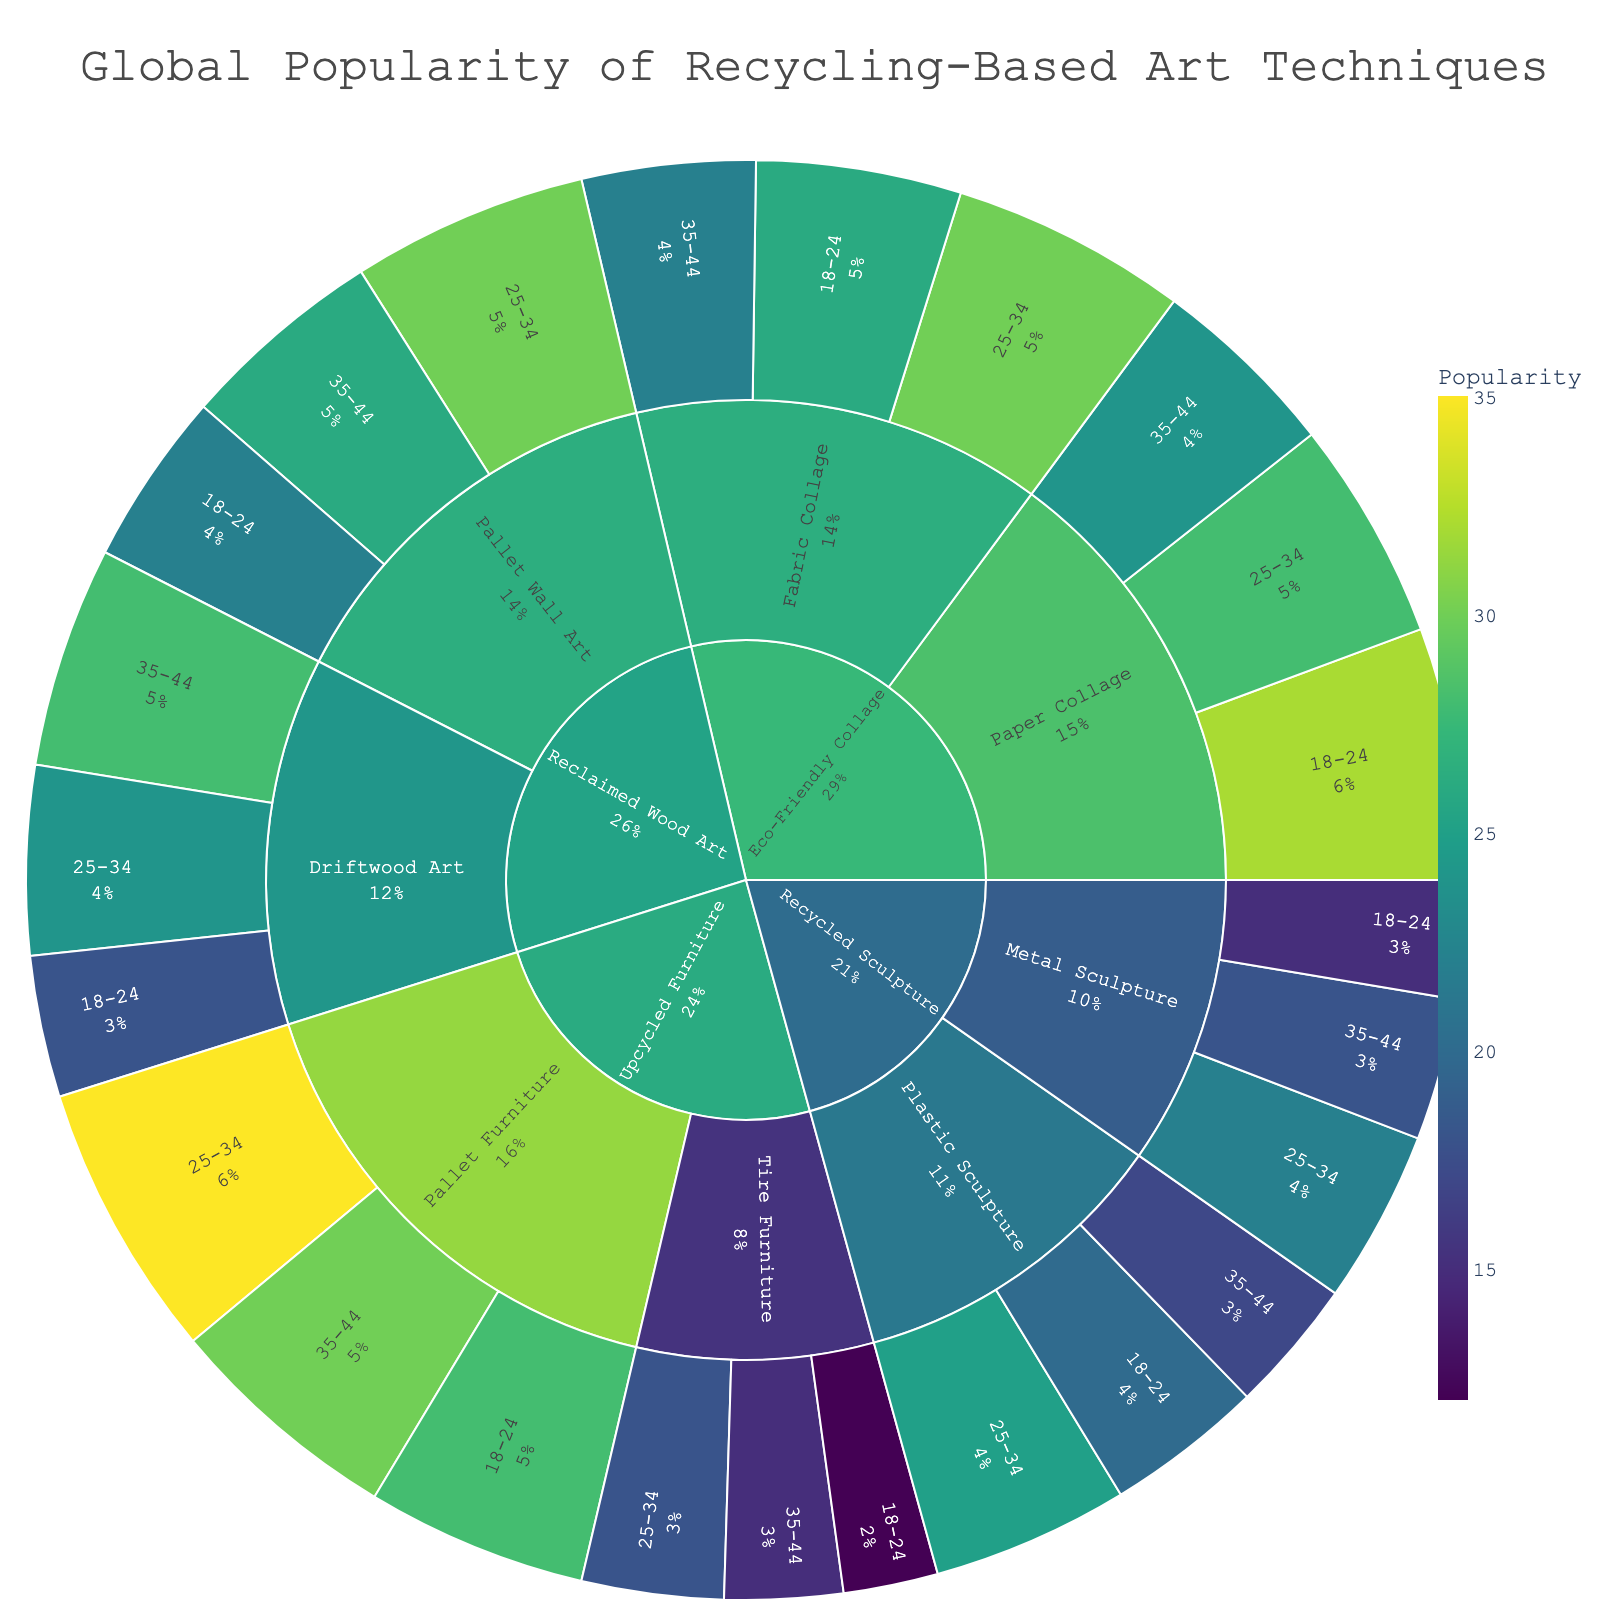Which age group is most popular for Paper Collage? Look for the segment labeled as "Paper Collage" and check the corresponding color's intensity for each age group. Then, identify which age group has the highest popularity number in the hover data.
Answer: 18-24 What is the total popularity for Driftwood Art across all age groups? Hover over the "Driftwood Art" segments for all age groups, and sum the popularity values: 18 (18-24) + 24 (25-34) + 28 (35-44).
Answer: 70 Which subcategory under "Upcycled Furniture" is more popular among 25-34-year-olds, Pallet Furniture or Tire Furniture? Compare the color intensities for "Pallet Furniture" and "Tire Furniture" under "Upcycled Furniture" for the 25-34 age group and examine the hover data for each subcategory.
Answer: Pallet Furniture How does the popularity of Plastic Sculpture among 25-34-year-olds compare to that of Fabric Collage among the same age group? Identify the color intensities and hover over the "Plastic Sculpture" and "Fabric Collage" segments for the 25-34 age group, then directly compare their popularity values.
Answer: Fabric Collage is more popular Which subcategory under "Reclaimed Wood Art" has the highest overall popularity, Pallet Wall Art or Driftwood Art? Check the color intensities and hover over the segments for both subcategories across all age groups, summing their popularity values: Driftwood Art (18+24+28) and Pallet Wall Art (22+30+26), then compare the sums.
Answer: Pallet Wall Art What's the average popularity of Metal Sculpture across all age groups? Hover over the "Metal Sculpture" segments for each age group and calculate the average: (15 + 22 + 18) / 3.
Answer: 18.33 Which age group shows the least interest in Tire Furniture? Examine the "Tire Furniture" segments' color intensities across age groups and identify the one with the lowest popularity value in the hover data.
Answer: 18-24 What is the difference in popularity between Pallet Furniture and Tire Furniture among 35-44-year-olds? Hover over "Pallet Furniture" and "Tire Furniture" segments for the 35-44 age group and subtract the popularity value of Tire Furniture from that of Pallet Furniture: 30 - 15.
Answer: 15 Which category has the most diverse popular subcategories based on age group popularity ranges? Assess the range of popularity values for each subcategory within a category across age groups, identifying the category with the widest range.
Answer: Eco-Friendly Collage 